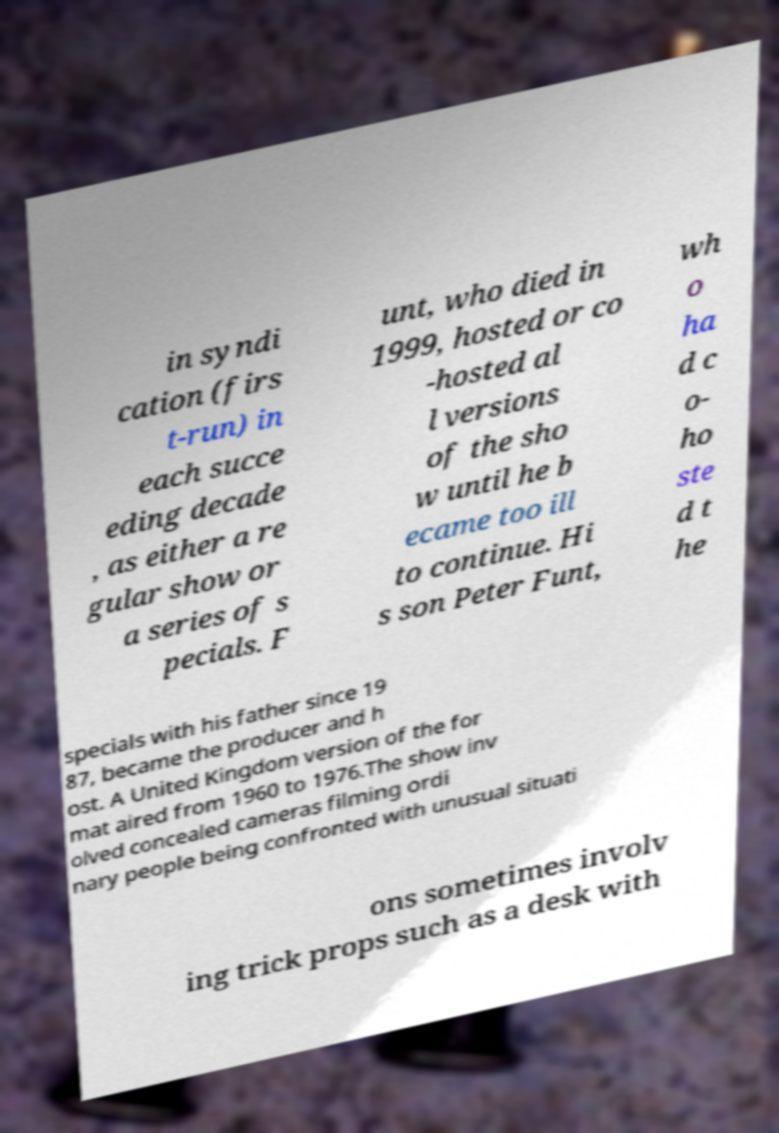Please read and relay the text visible in this image. What does it say? in syndi cation (firs t-run) in each succe eding decade , as either a re gular show or a series of s pecials. F unt, who died in 1999, hosted or co -hosted al l versions of the sho w until he b ecame too ill to continue. Hi s son Peter Funt, wh o ha d c o- ho ste d t he specials with his father since 19 87, became the producer and h ost. A United Kingdom version of the for mat aired from 1960 to 1976.The show inv olved concealed cameras filming ordi nary people being confronted with unusual situati ons sometimes involv ing trick props such as a desk with 